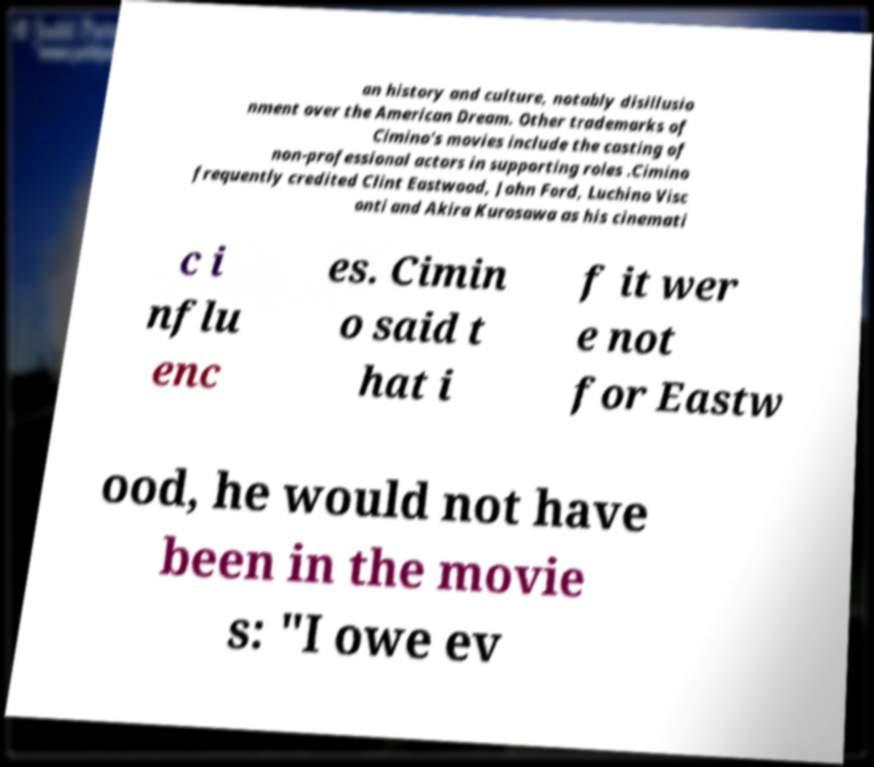Could you assist in decoding the text presented in this image and type it out clearly? an history and culture, notably disillusio nment over the American Dream. Other trademarks of Cimino's movies include the casting of non-professional actors in supporting roles .Cimino frequently credited Clint Eastwood, John Ford, Luchino Visc onti and Akira Kurosawa as his cinemati c i nflu enc es. Cimin o said t hat i f it wer e not for Eastw ood, he would not have been in the movie s: "I owe ev 